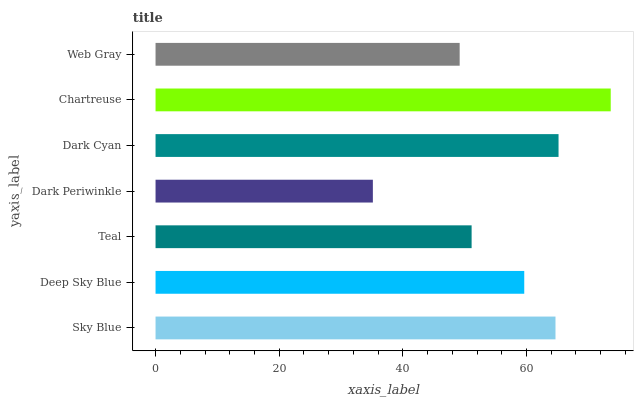Is Dark Periwinkle the minimum?
Answer yes or no. Yes. Is Chartreuse the maximum?
Answer yes or no. Yes. Is Deep Sky Blue the minimum?
Answer yes or no. No. Is Deep Sky Blue the maximum?
Answer yes or no. No. Is Sky Blue greater than Deep Sky Blue?
Answer yes or no. Yes. Is Deep Sky Blue less than Sky Blue?
Answer yes or no. Yes. Is Deep Sky Blue greater than Sky Blue?
Answer yes or no. No. Is Sky Blue less than Deep Sky Blue?
Answer yes or no. No. Is Deep Sky Blue the high median?
Answer yes or no. Yes. Is Deep Sky Blue the low median?
Answer yes or no. Yes. Is Dark Cyan the high median?
Answer yes or no. No. Is Teal the low median?
Answer yes or no. No. 